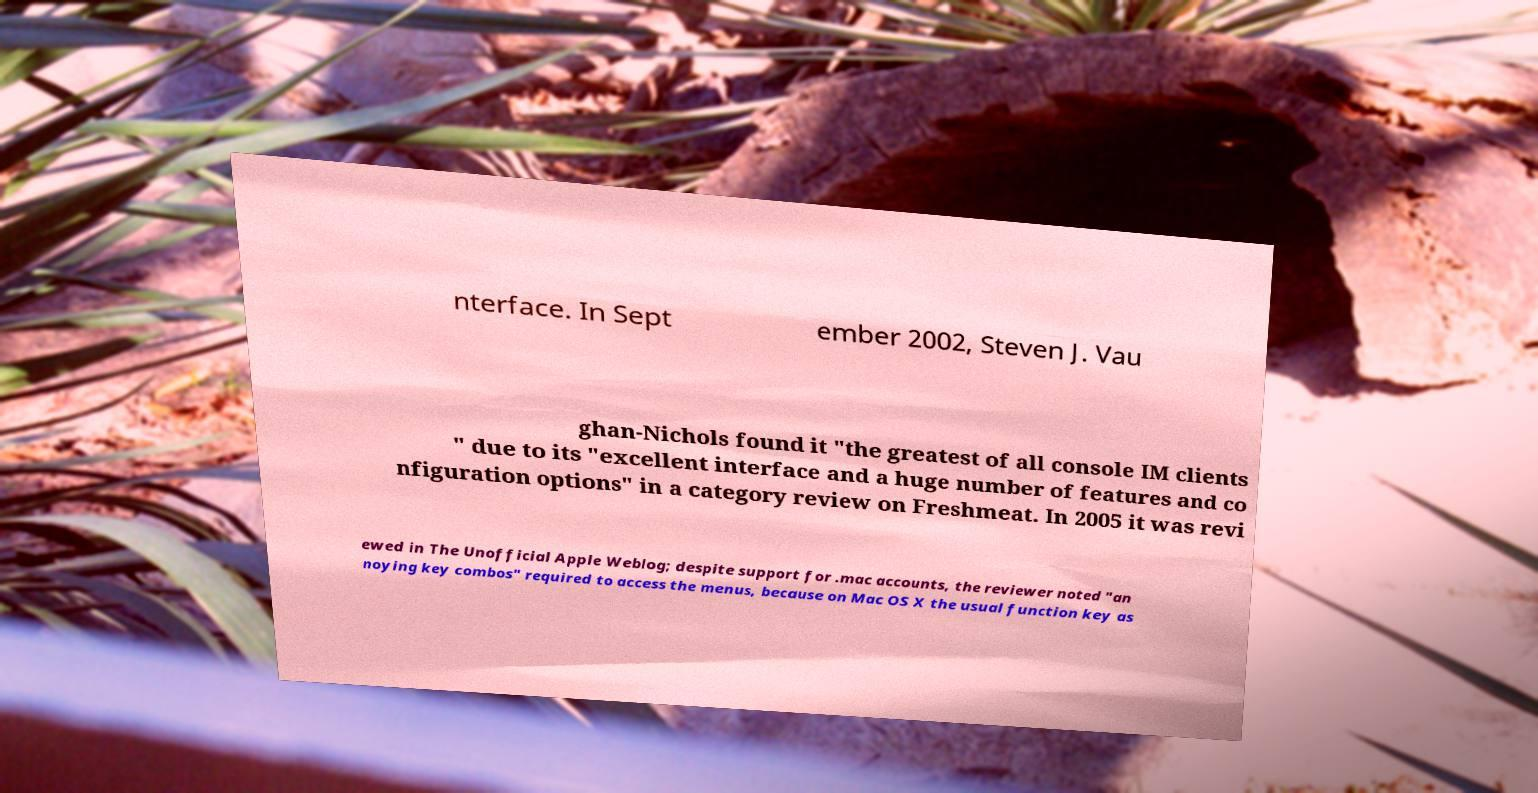There's text embedded in this image that I need extracted. Can you transcribe it verbatim? nterface. In Sept ember 2002, Steven J. Vau ghan-Nichols found it "the greatest of all console IM clients " due to its "excellent interface and a huge number of features and co nfiguration options" in a category review on Freshmeat. In 2005 it was revi ewed in The Unofficial Apple Weblog; despite support for .mac accounts, the reviewer noted "an noying key combos" required to access the menus, because on Mac OS X the usual function key as 